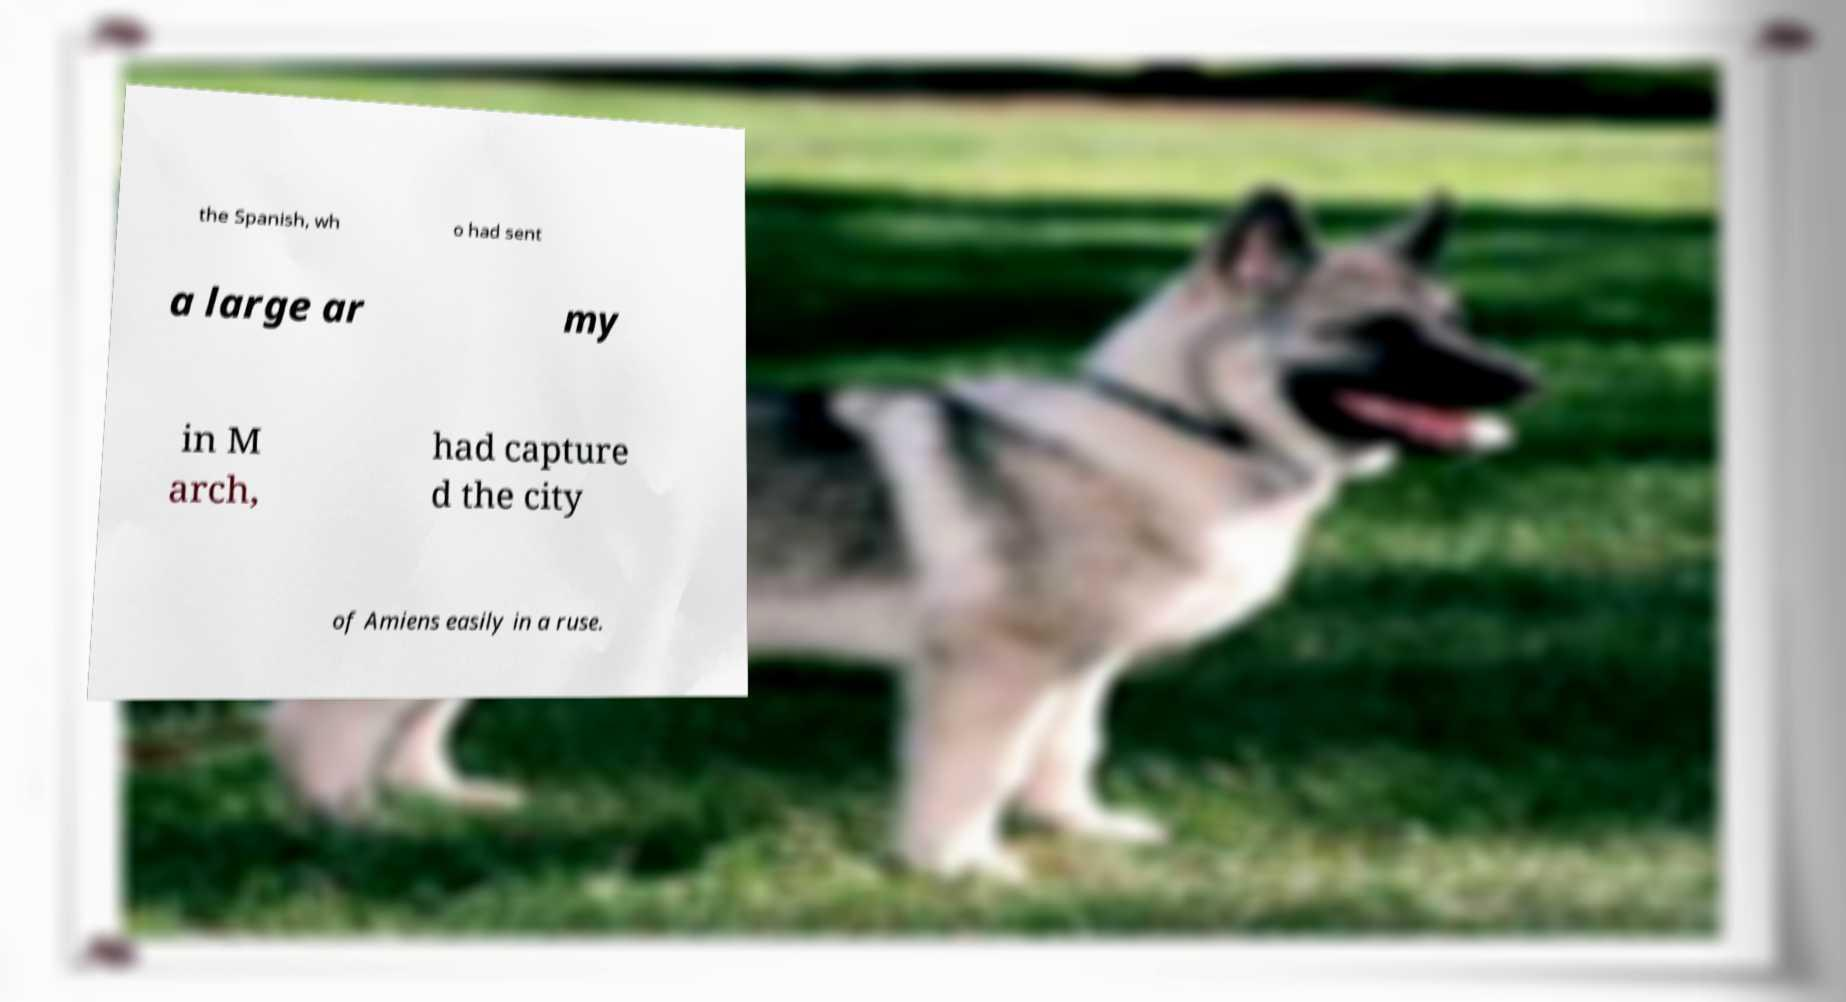Please read and relay the text visible in this image. What does it say? the Spanish, wh o had sent a large ar my in M arch, had capture d the city of Amiens easily in a ruse. 